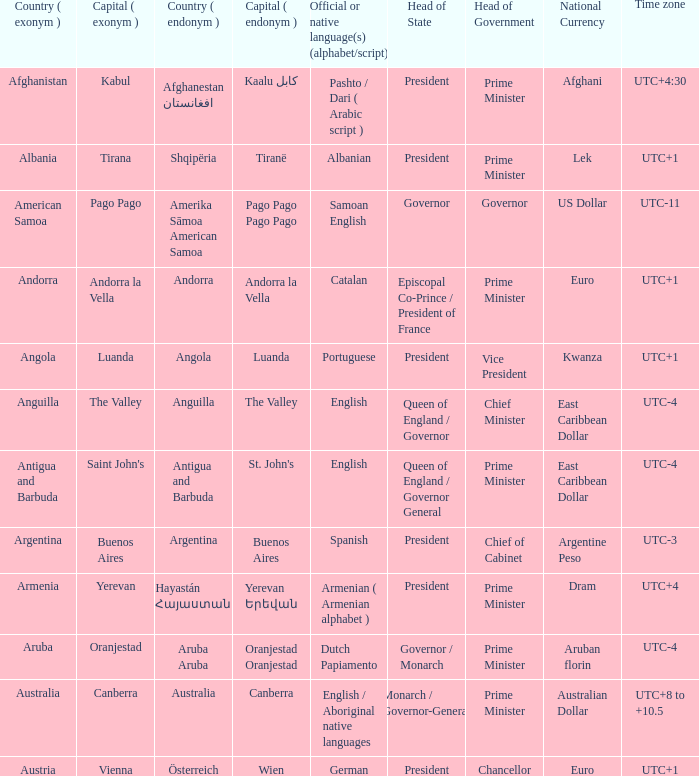What official or native languages are spoken in the country whose capital city is Canberra? English / Aboriginal native languages. 